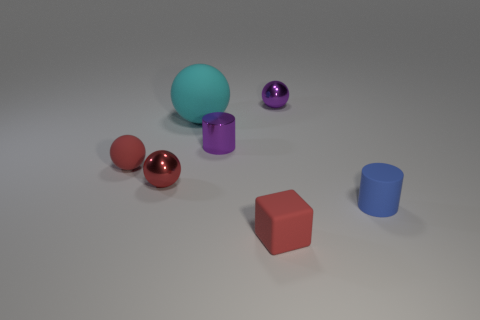Subtract 1 spheres. How many spheres are left? 3 Add 3 metal cylinders. How many objects exist? 10 Subtract all balls. How many objects are left? 3 Add 1 metallic objects. How many metallic objects are left? 4 Add 1 blue cylinders. How many blue cylinders exist? 2 Subtract 0 yellow cylinders. How many objects are left? 7 Subtract all cyan spheres. Subtract all tiny rubber cubes. How many objects are left? 5 